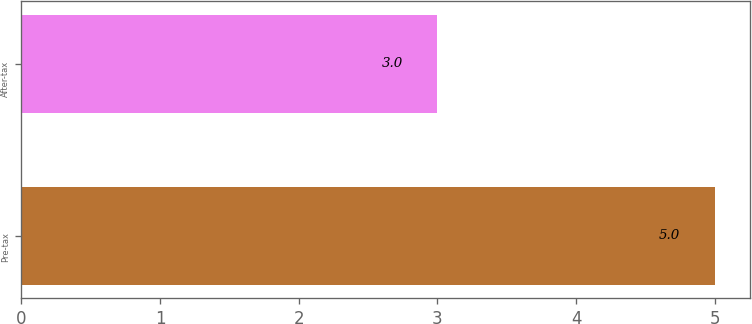Convert chart. <chart><loc_0><loc_0><loc_500><loc_500><bar_chart><fcel>Pre-tax<fcel>After-tax<nl><fcel>5<fcel>3<nl></chart> 